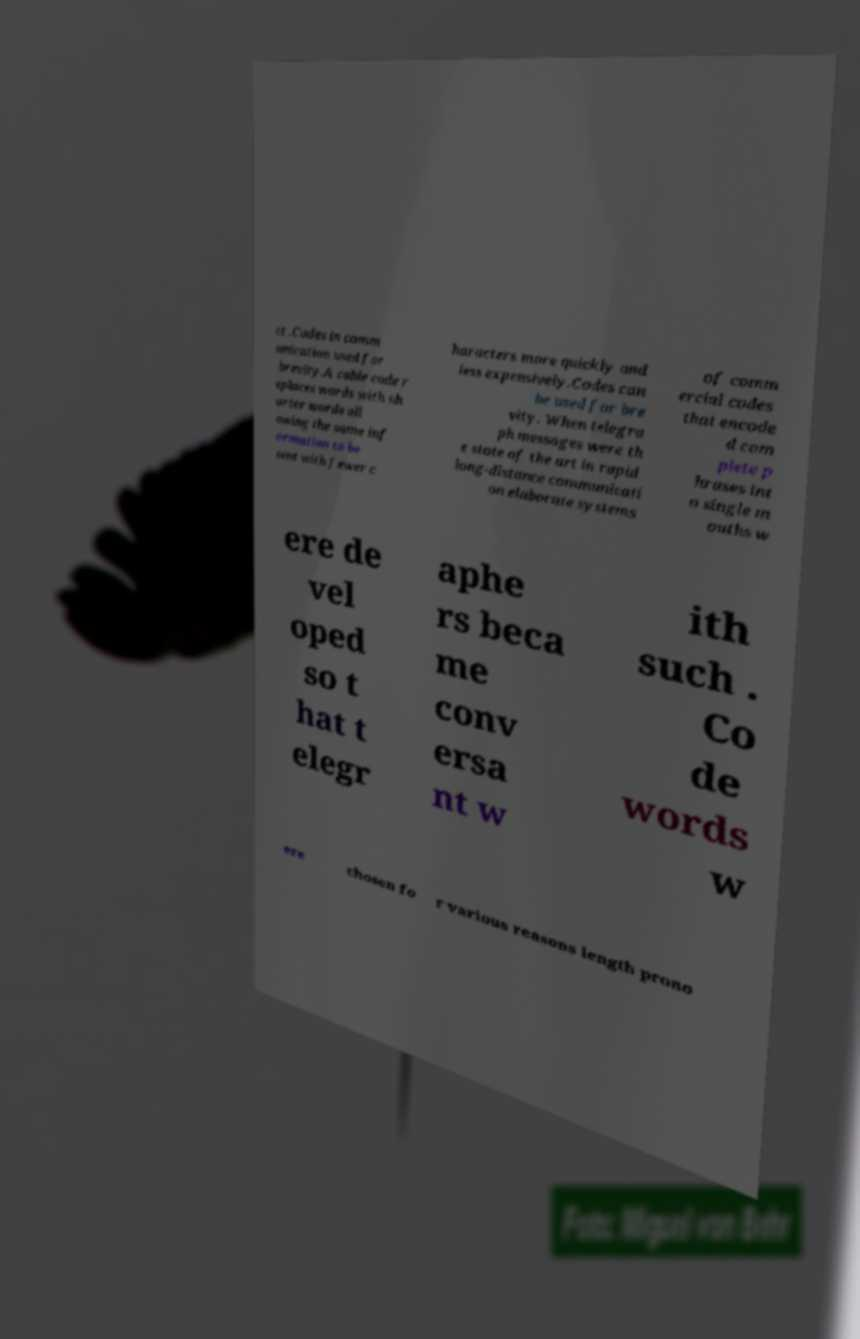Please identify and transcribe the text found in this image. ct .Codes in comm unication used for brevity.A cable code r eplaces words with sh orter words all owing the same inf ormation to be sent with fewer c haracters more quickly and less expensively.Codes can be used for bre vity. When telegra ph messages were th e state of the art in rapid long-distance communicati on elaborate systems of comm ercial codes that encode d com plete p hrases int o single m ouths w ere de vel oped so t hat t elegr aphe rs beca me conv ersa nt w ith such . Co de words w ere chosen fo r various reasons length prono 